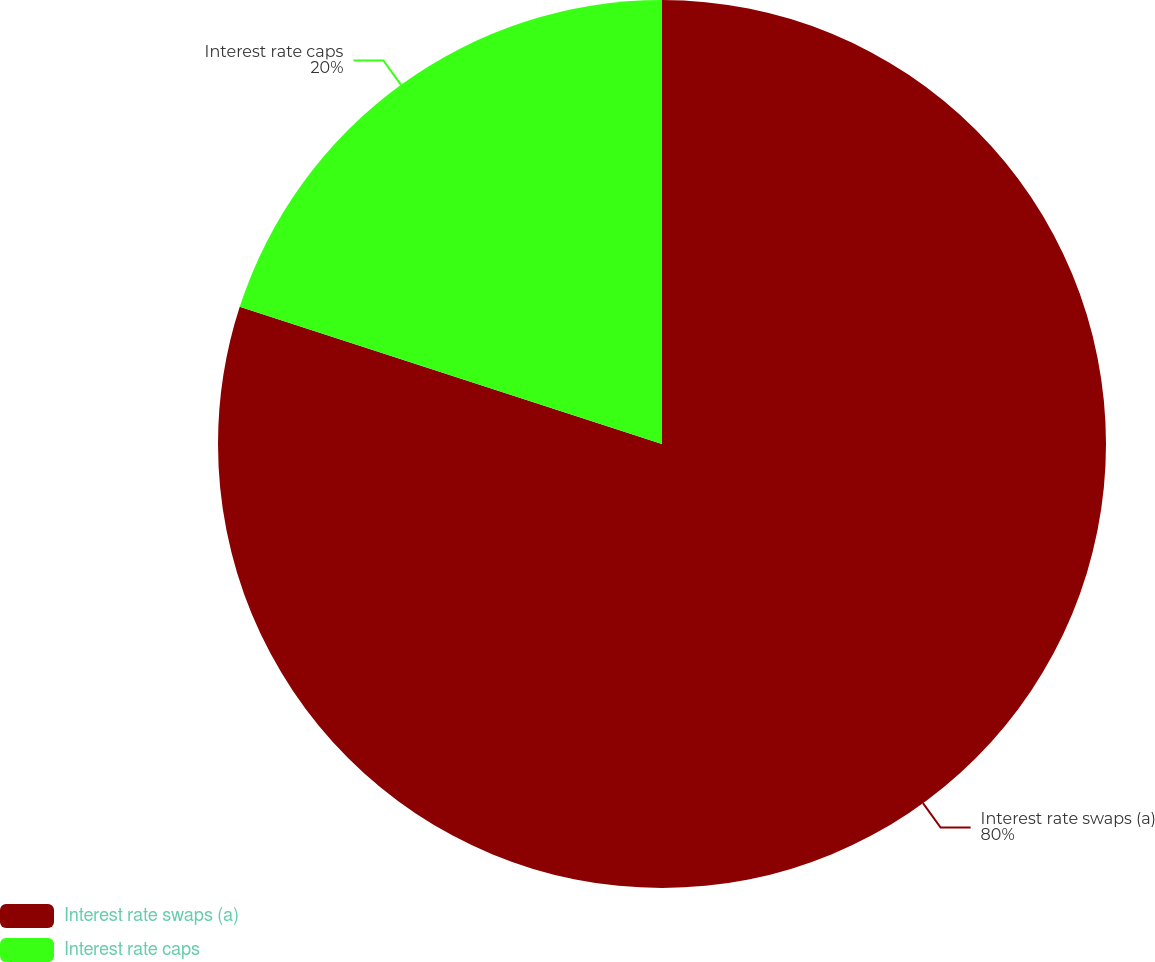Convert chart. <chart><loc_0><loc_0><loc_500><loc_500><pie_chart><fcel>Interest rate swaps (a)<fcel>Interest rate caps<nl><fcel>80.0%<fcel>20.0%<nl></chart> 